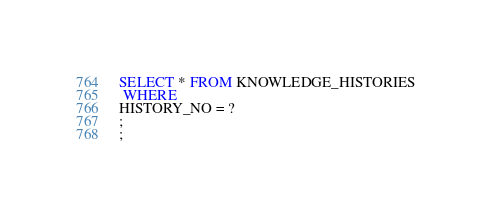Convert code to text. <code><loc_0><loc_0><loc_500><loc_500><_SQL_>SELECT * FROM KNOWLEDGE_HISTORIES
 WHERE 
HISTORY_NO = ?
;
;
</code> 